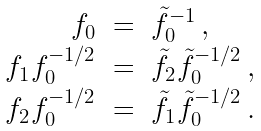<formula> <loc_0><loc_0><loc_500><loc_500>\begin{array} { r l l } f _ { 0 } & = & \tilde { f } _ { 0 } ^ { - 1 } \, , \\ f _ { 1 } f _ { 0 } ^ { - 1 / 2 } & = & \tilde { f } _ { 2 } \tilde { f } _ { 0 } ^ { - 1 / 2 } \, , \\ f _ { 2 } f _ { 0 } ^ { - 1 / 2 } & = & \tilde { f } _ { 1 } \tilde { f } _ { 0 } ^ { - 1 / 2 } \, . \end{array}</formula> 